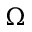Convert formula to latex. <formula><loc_0><loc_0><loc_500><loc_500>\Omega</formula> 